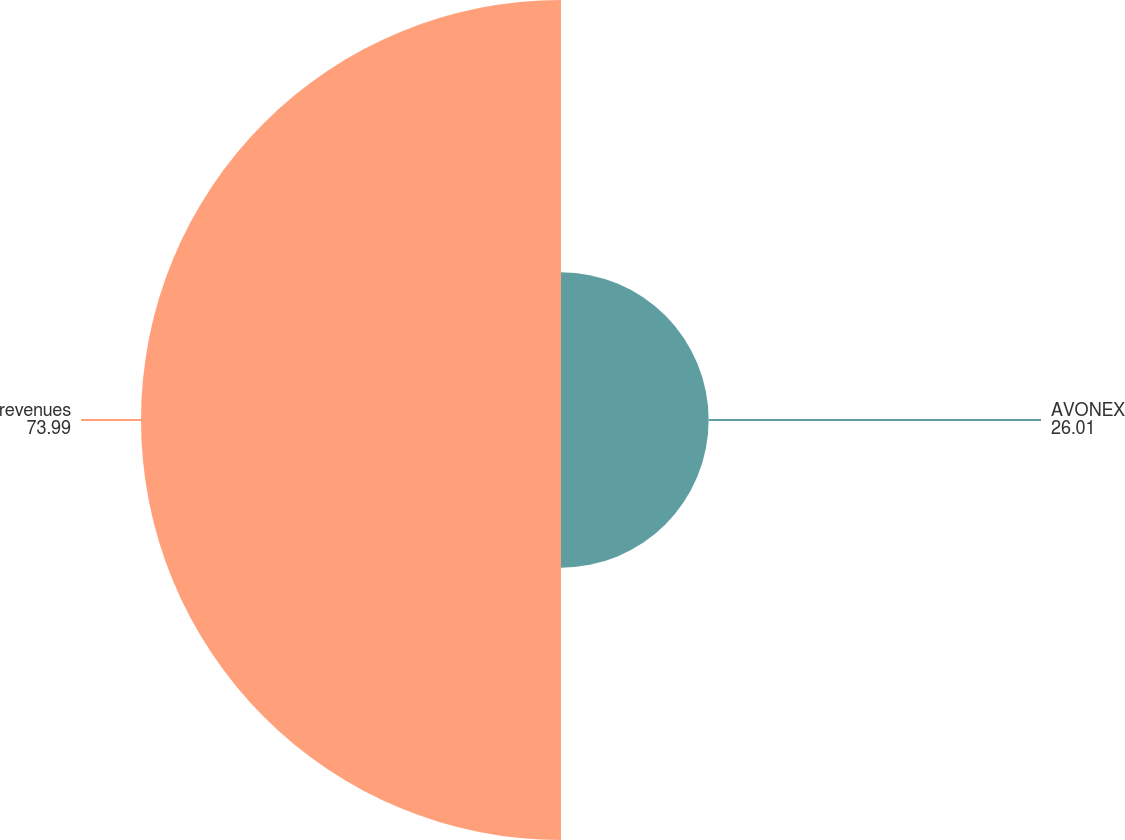Convert chart. <chart><loc_0><loc_0><loc_500><loc_500><pie_chart><fcel>AVONEX<fcel>revenues<nl><fcel>26.01%<fcel>73.99%<nl></chart> 